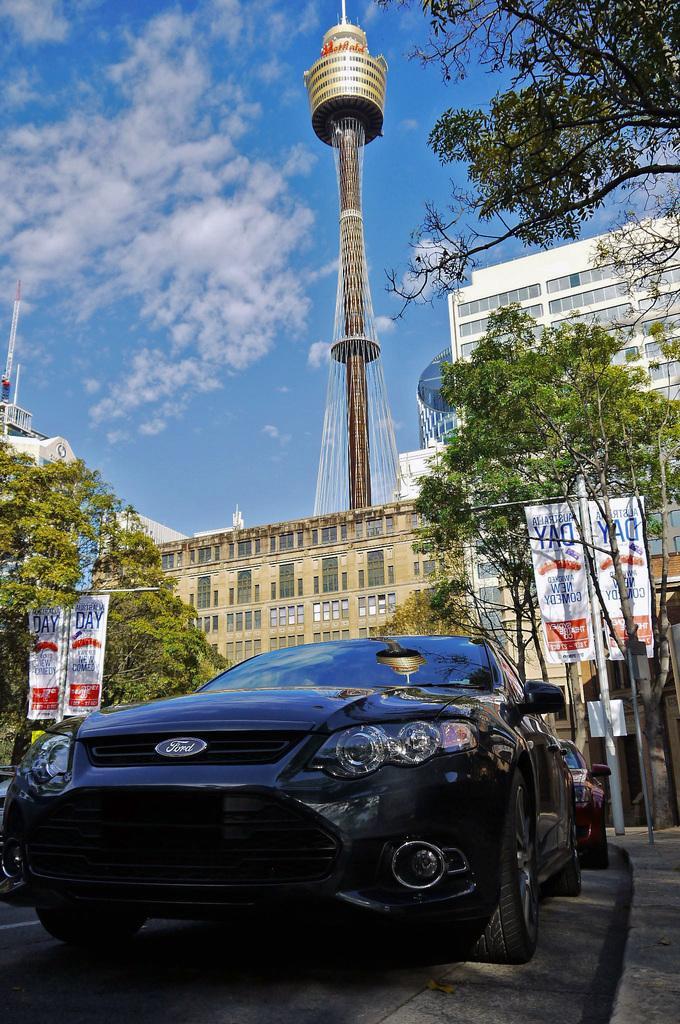Can you describe this image briefly? In this image we can see a few vehicles on the road, few trees, few banners attached to the poles, few buildings, few towers and some clouds in the sky. 